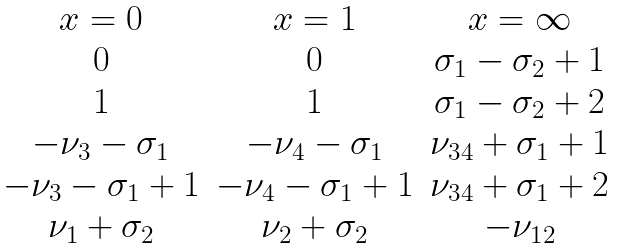<formula> <loc_0><loc_0><loc_500><loc_500>\begin{matrix} x = 0 & x = 1 & x = \infty \\ 0 & 0 & \sigma _ { 1 } - \sigma _ { 2 } + 1 \\ 1 & 1 & \sigma _ { 1 } - \sigma _ { 2 } + 2 \\ - \nu _ { 3 } - \sigma _ { 1 } & - \nu _ { 4 } - \sigma _ { 1 } & \nu _ { 3 4 } + \sigma _ { 1 } + 1 \\ - \nu _ { 3 } - \sigma _ { 1 } + 1 & - \nu _ { 4 } - \sigma _ { 1 } + 1 & \nu _ { 3 4 } + \sigma _ { 1 } + 2 \\ \nu _ { 1 } + \sigma _ { 2 } & \nu _ { 2 } + \sigma _ { 2 } & - \nu _ { 1 2 } \end{matrix}</formula> 